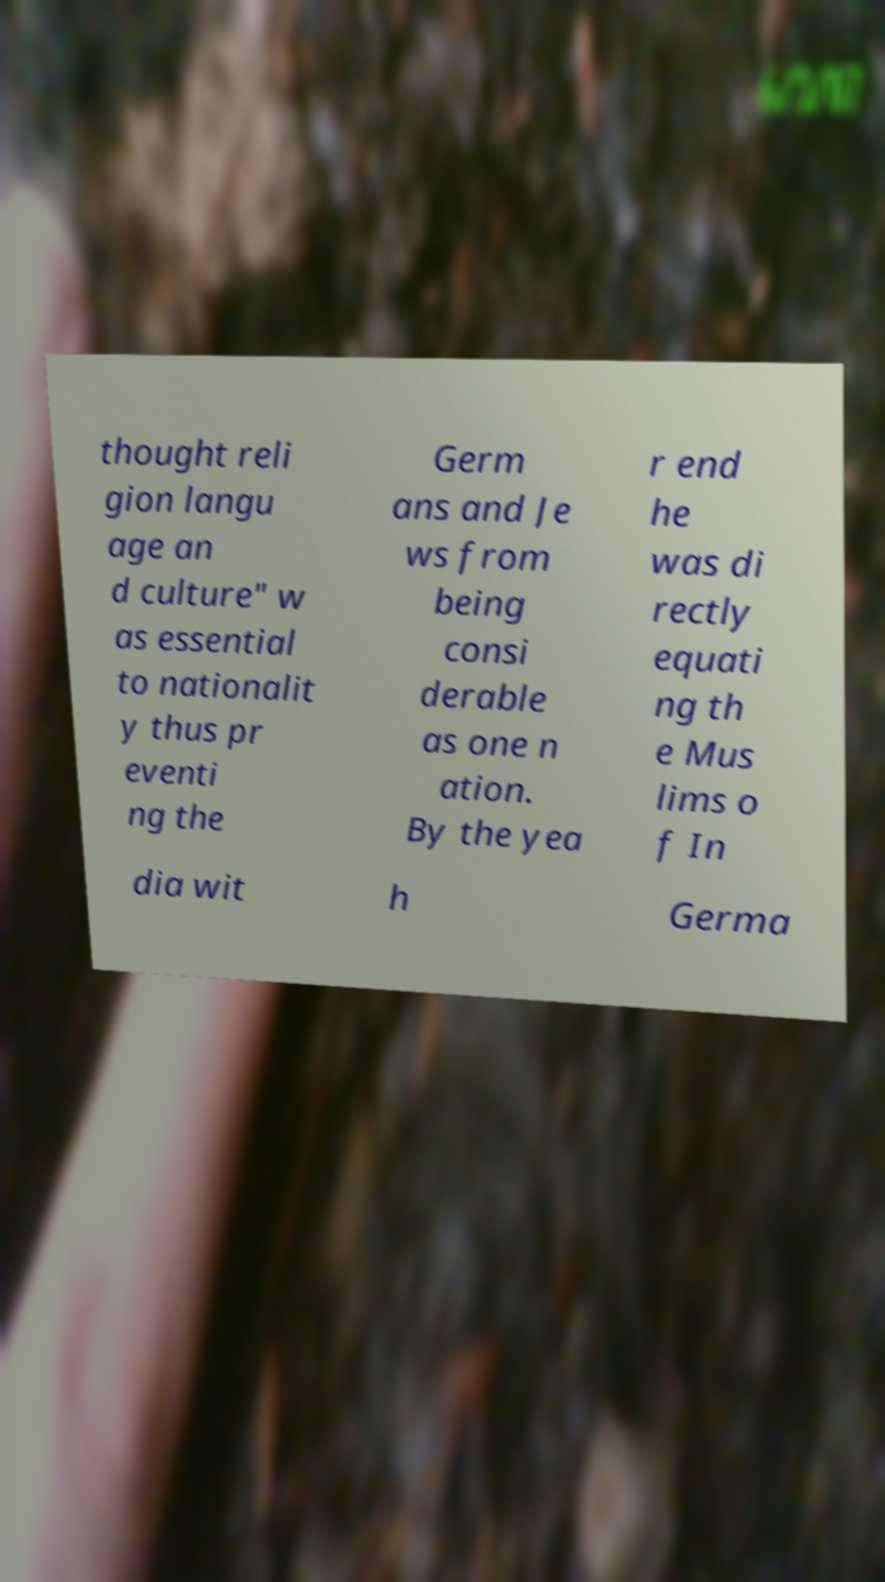Could you extract and type out the text from this image? thought reli gion langu age an d culture" w as essential to nationalit y thus pr eventi ng the Germ ans and Je ws from being consi derable as one n ation. By the yea r end he was di rectly equati ng th e Mus lims o f In dia wit h Germa 